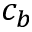Convert formula to latex. <formula><loc_0><loc_0><loc_500><loc_500>c _ { b }</formula> 